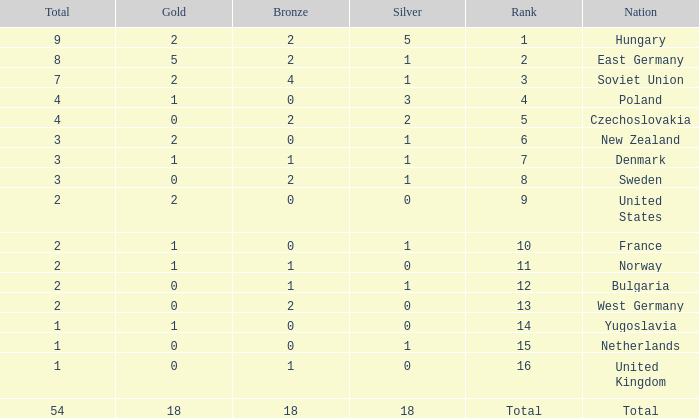What is the lowest total for those receiving less than 18 but more than 14? 1.0. 